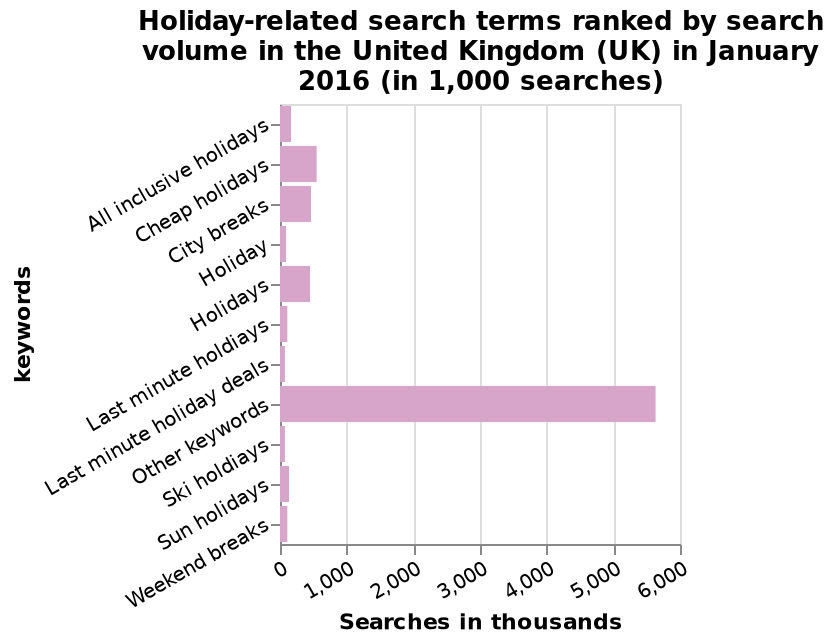<image>
What was the trend in search keywords for holidays in the UK since 2016?  Keywords other than those selected in the bar chart were used more frequently in searches related to holidays in the UK since 2016. please summary the statistics and relations of the chart Keywords other than those selected in the bar chart were used far more frequently in searches made in the Uk related to holidays since 2016. The most common keyword included in the bar chart was cheap holidays. What does the y-axis represent in the bar chart?  The y-axis represents keywords related to holidays. What does each bar in the chart represent? Each bar represents the search volume for a specific holiday-related keyword. 